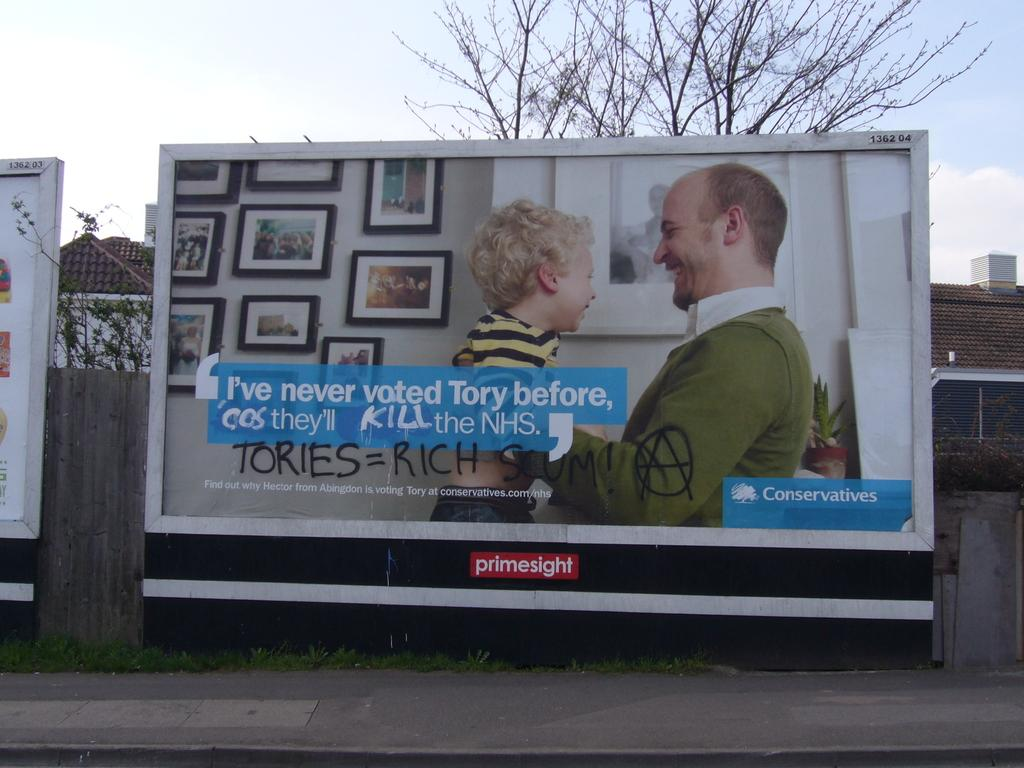<image>
Present a compact description of the photo's key features. A billboard with a logo that reads primesight advertises a man and a boy. 